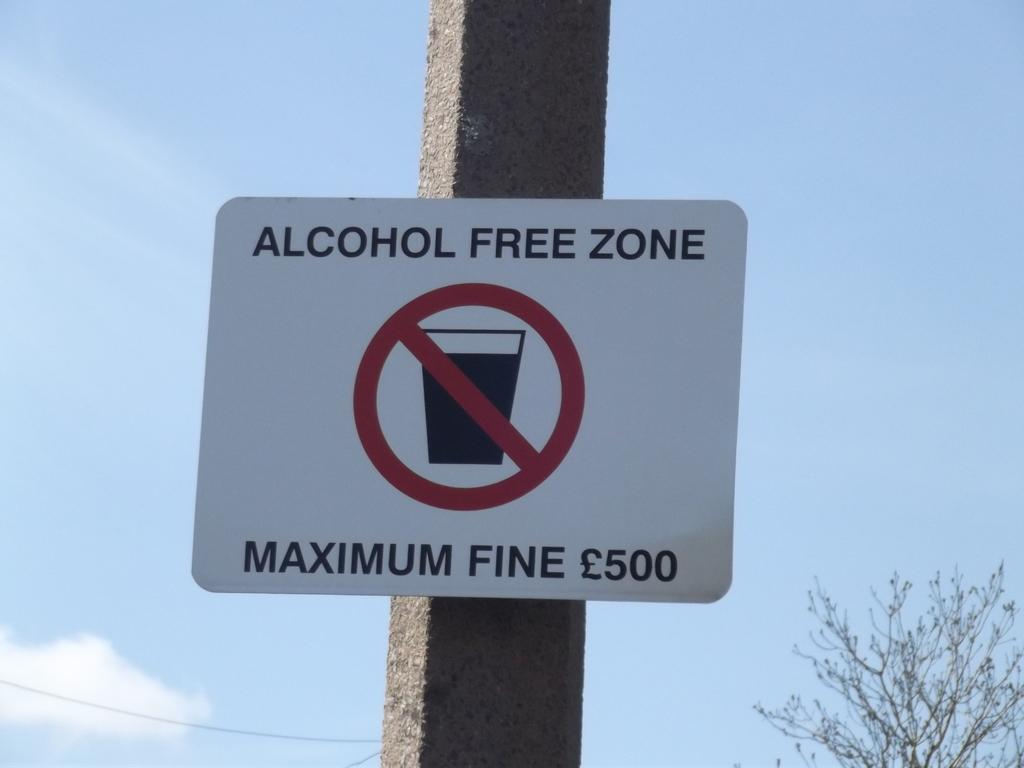What is attached to the pole in the image? There is a board attached to the pole in the image. What can be seen on the board? The board has text on it. What is visible in the background of the image? There is sky and a tree visible in the background of the image. What type of substance is being measured with the calculator in the image? There is no calculator present in the image; it features a pole with a board and a tree in the background. Can you tell me how many guns are visible in the image? There are no guns present in the image. 